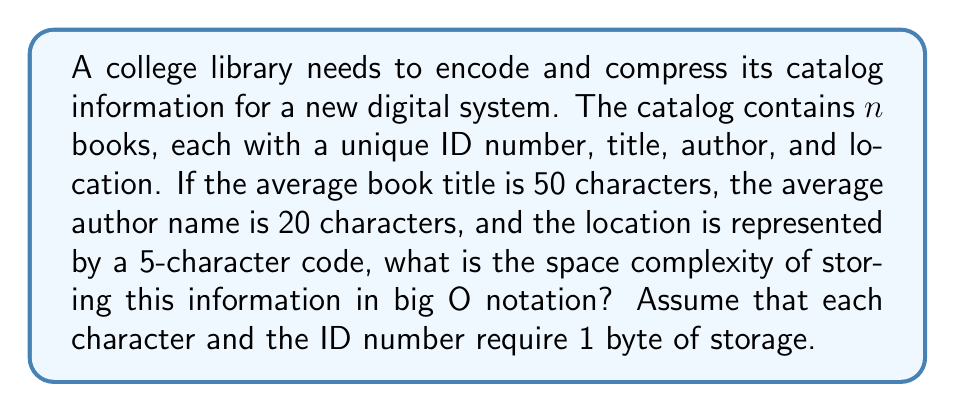Help me with this question. Let's break down the problem step-by-step:

1. For each book, we need to store:
   - ID number: 1 byte
   - Title: 50 bytes (average)
   - Author: 20 bytes (average)
   - Location: 5 bytes

2. Total bytes per book = 1 + 50 + 20 + 5 = 76 bytes

3. For $n$ books, the total storage required would be $76n$ bytes.

4. In big O notation, we ignore constant factors. Therefore, the space complexity is $O(n)$.

5. Even if we were to compress this data, the space complexity would still be $O(n)$ because:
   - The best compression algorithms can't reduce the size below a certain fraction of the original size.
   - The compressed size would still grow linearly with the number of books.

6. The space complexity remains $O(n)$ regardless of the specific encoding or compression method used, as long as each book's information is stored individually.

This linear space complexity is typical for database-like structures where each entry (in this case, each book) requires a fixed amount of information to be stored.
Answer: The space complexity of encoding and compressing the library catalog information is $O(n)$, where $n$ is the number of books in the catalog. 